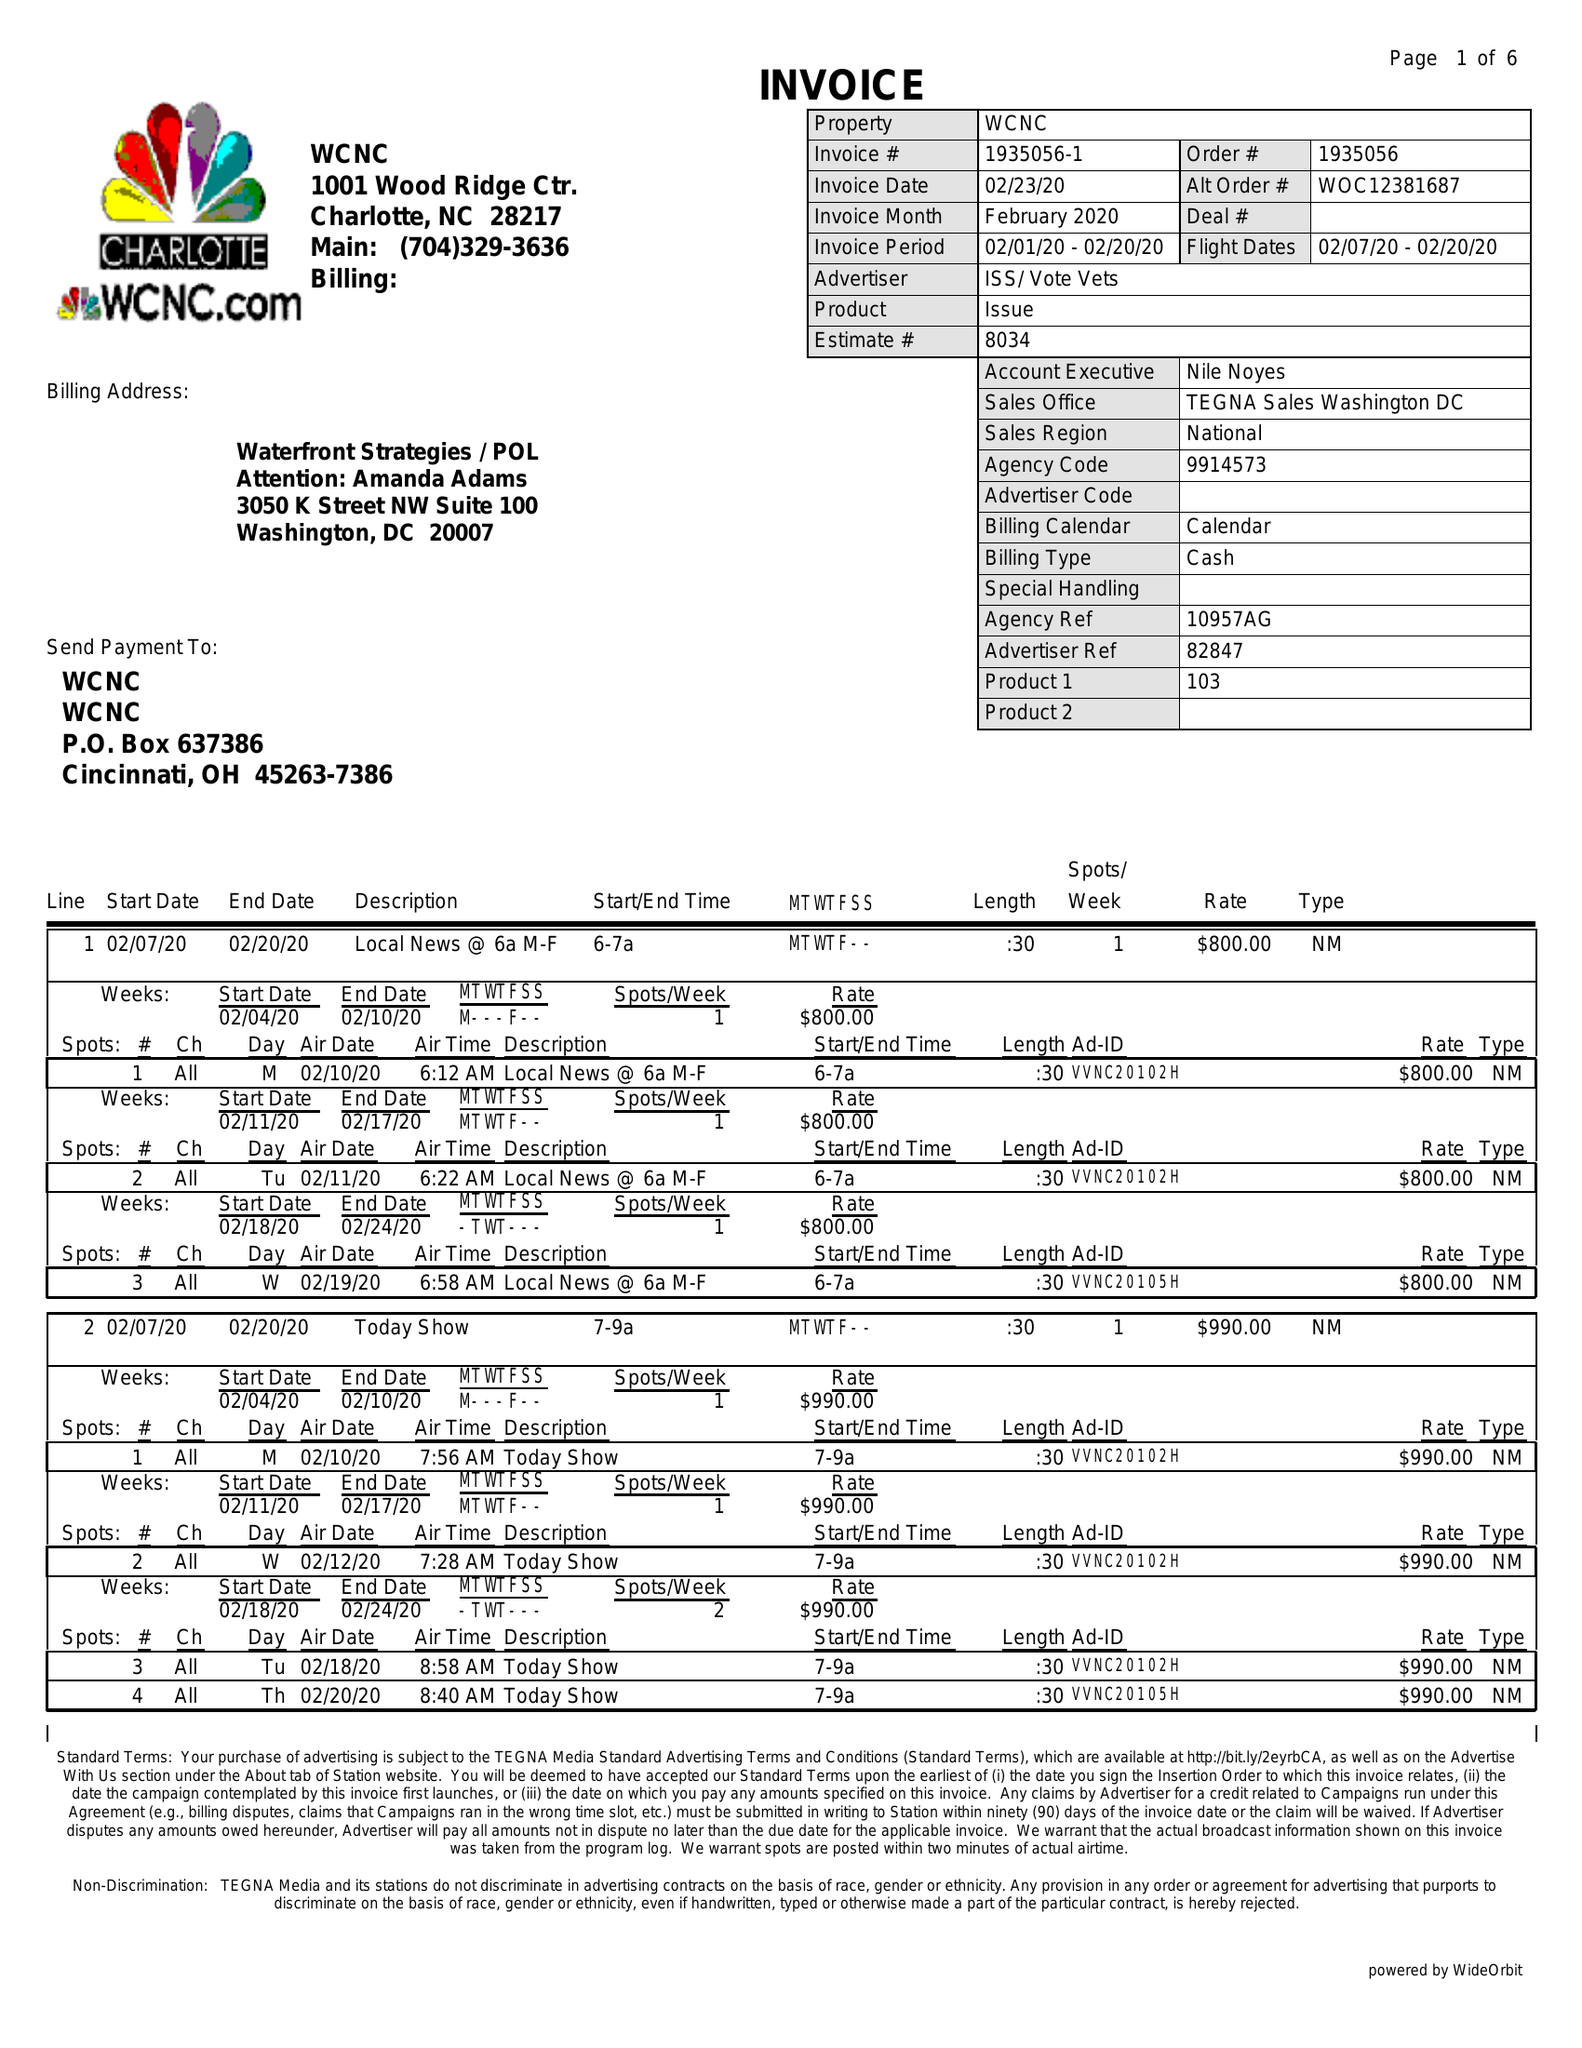What is the value for the contract_num?
Answer the question using a single word or phrase. 1935056 